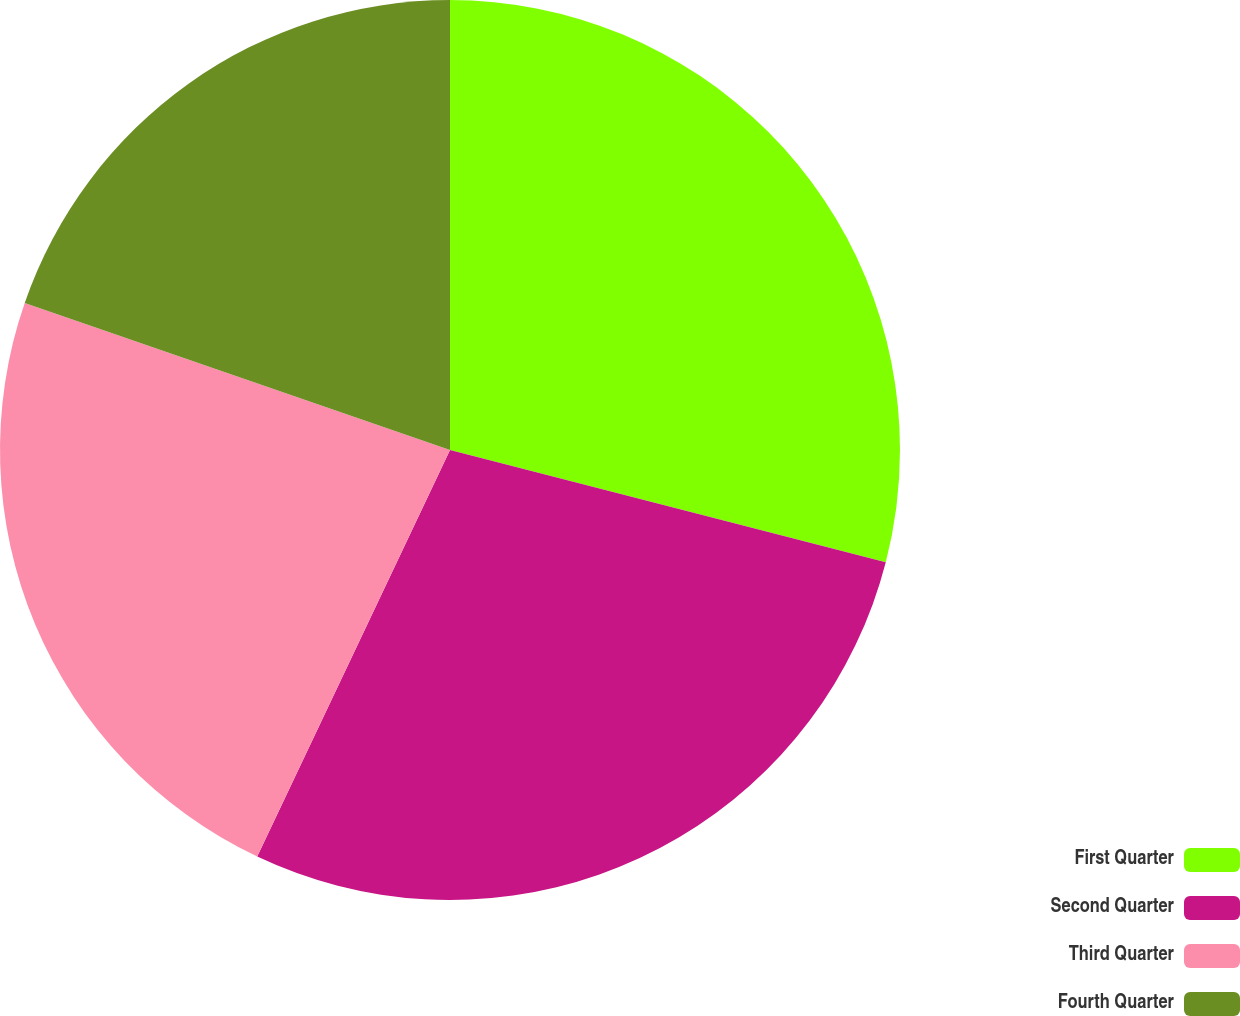<chart> <loc_0><loc_0><loc_500><loc_500><pie_chart><fcel>First Quarter<fcel>Second Quarter<fcel>Third Quarter<fcel>Fourth Quarter<nl><fcel>29.01%<fcel>28.03%<fcel>23.25%<fcel>19.7%<nl></chart> 